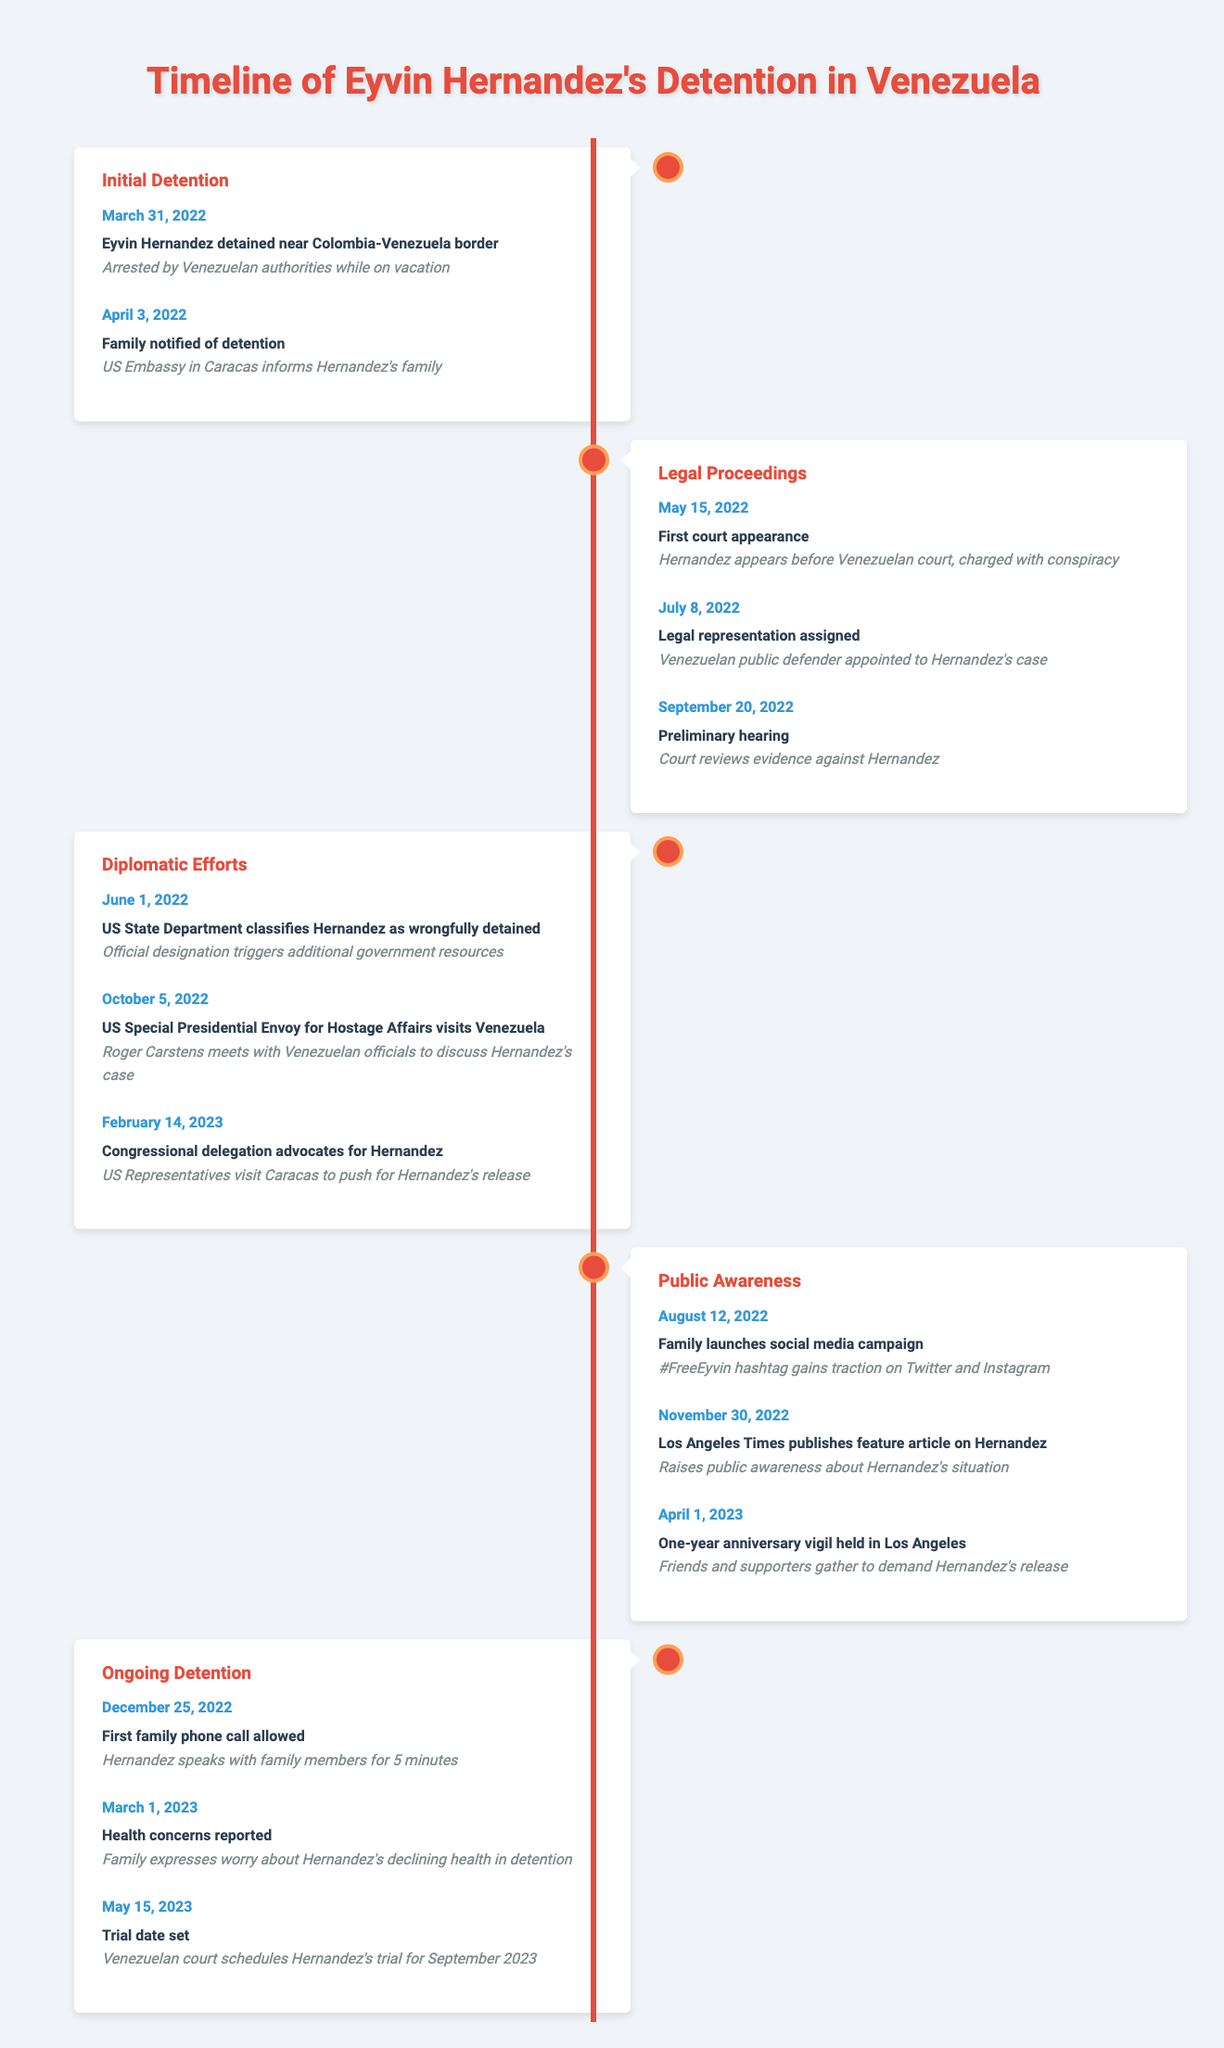What date was Eyvin Hernandez detained? According to the table, Eyvin Hernandez was detained on March 31, 2022, near the Colombia-Venezuela border.
Answer: March 31, 2022 When did Eyvin's family first find out about his detention? The table shows that Eyvin's family was notified of his detention on April 3, 2022, by the US Embassy in Caracas.
Answer: April 3, 2022 What charge was Eyvin Hernandez facing during his first court appearance? The event on May 15, 2022, indicates that he was charged with conspiracy during his first court appearance.
Answer: Conspiracy How many events occurred during the "Diplomatic Efforts" phase? By counting the events listed under the "Diplomatic Efforts" phase, there are three events: one on June 1, another on October 5, and a third on February 14, 2023.
Answer: Three Did Eyvin Hernandez receive any legal representation before his trial date was set? Yes, the table indicates that a Venezuelan public defender was assigned to his case on July 8, 2022, before the trial date was set.
Answer: Yes What was a significant action taken by the US State Department regarding Eyvin? The table notes that on June 1, 2022, the US State Department classified Hernandez as wrongfully detained, which is a significant action regarding his case.
Answer: Classified as wrongfully detained When was Hernandez's first family phone call allowed? According to the timeline, the first family phone call was allowed on December 25, 2022.
Answer: December 25, 2022 How much time elapsed between Eyvin Hernandez's initial detention and the first family phone call? Eyvin was detained on March 31, 2022, and the first family phone call occurred on December 25, 2022. From March 31 to December 25 is approximately 8 months and 25 days.
Answer: About 8 months and 25 days What event raised public awareness about Hernandez's situation? The publication of a feature article about Hernandez in the Los Angeles Times on November 30, 2022, is noted as a key event that raised public awareness.
Answer: Los Angeles Times article What health concerns were reported regarding Eyvin Hernandez? The table shows that on March 1, 2023, it was reported that family members expressed worry about Hernandez's declining health in detention.
Answer: Declining health concerns How does the frequency of events in the "Legal Proceedings" phase compare to the "Public Awareness" phase? There are three events in the "Legal Proceedings" phase and three events in the "Public Awareness" phase, indicating that both phases have the same frequency of events.
Answer: Same frequency (three each) 